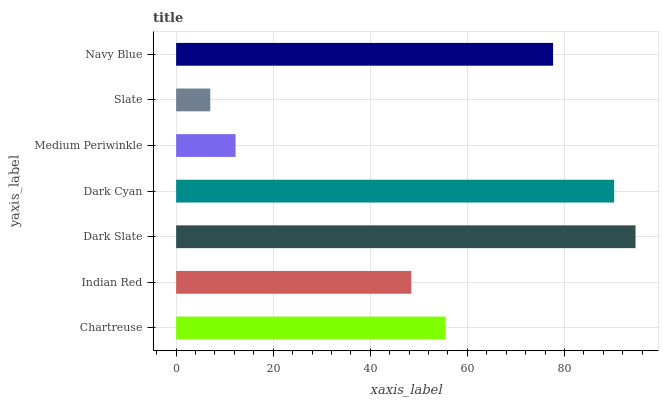Is Slate the minimum?
Answer yes or no. Yes. Is Dark Slate the maximum?
Answer yes or no. Yes. Is Indian Red the minimum?
Answer yes or no. No. Is Indian Red the maximum?
Answer yes or no. No. Is Chartreuse greater than Indian Red?
Answer yes or no. Yes. Is Indian Red less than Chartreuse?
Answer yes or no. Yes. Is Indian Red greater than Chartreuse?
Answer yes or no. No. Is Chartreuse less than Indian Red?
Answer yes or no. No. Is Chartreuse the high median?
Answer yes or no. Yes. Is Chartreuse the low median?
Answer yes or no. Yes. Is Slate the high median?
Answer yes or no. No. Is Dark Slate the low median?
Answer yes or no. No. 